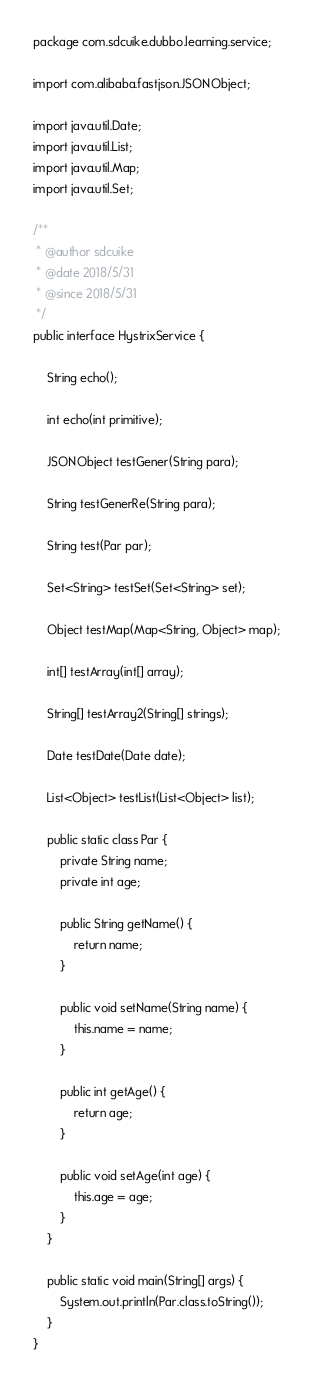<code> <loc_0><loc_0><loc_500><loc_500><_Java_>package com.sdcuike.dubbo.learning.service;

import com.alibaba.fastjson.JSONObject;

import java.util.Date;
import java.util.List;
import java.util.Map;
import java.util.Set;

/**
 * @author sdcuike
 * @date 2018/5/31
 * @since 2018/5/31
 */
public interface HystrixService {

    String echo();

    int echo(int primitive);

    JSONObject testGener(String para);

    String testGenerRe(String para);

    String test(Par par);

    Set<String> testSet(Set<String> set);

    Object testMap(Map<String, Object> map);

    int[] testArray(int[] array);

    String[] testArray2(String[] strings);

    Date testDate(Date date);

    List<Object> testList(List<Object> list);

    public static class Par {
        private String name;
        private int age;

        public String getName() {
            return name;
        }

        public void setName(String name) {
            this.name = name;
        }

        public int getAge() {
            return age;
        }

        public void setAge(int age) {
            this.age = age;
        }
    }

    public static void main(String[] args) {
        System.out.println(Par.class.toString());
    }
}
</code> 